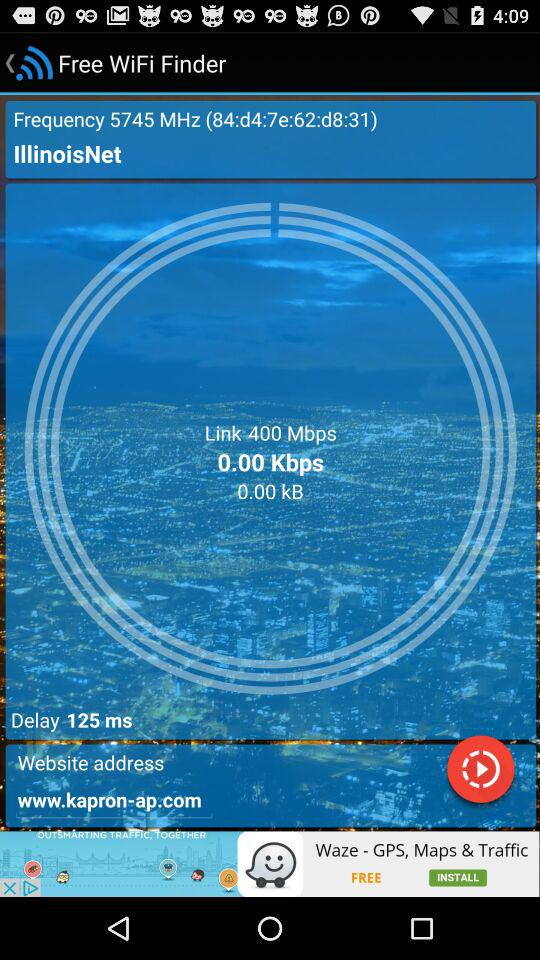What is the frequency? The frequency is 5745 MHz. 